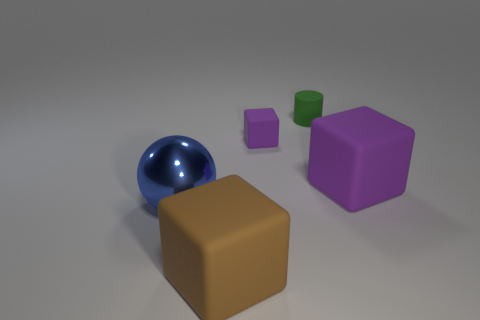Subtract all purple blocks. How many blocks are left? 1 Add 5 large matte cubes. How many objects exist? 10 Subtract all brown blocks. How many blocks are left? 2 Subtract 2 cubes. How many cubes are left? 1 Subtract all balls. How many objects are left? 4 Subtract all red cubes. Subtract all cyan cylinders. How many cubes are left? 3 Subtract all gray spheres. How many green cubes are left? 0 Subtract all small brown cylinders. Subtract all large brown cubes. How many objects are left? 4 Add 5 large blue things. How many large blue things are left? 6 Add 1 shiny balls. How many shiny balls exist? 2 